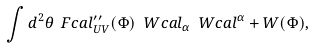Convert formula to latex. <formula><loc_0><loc_0><loc_500><loc_500>\int d ^ { 2 } \theta \ F c a l _ { U V } ^ { \prime \prime } ( \Phi ) \ W c a l _ { \alpha } \ W c a l ^ { \alpha } + W ( \Phi ) ,</formula> 